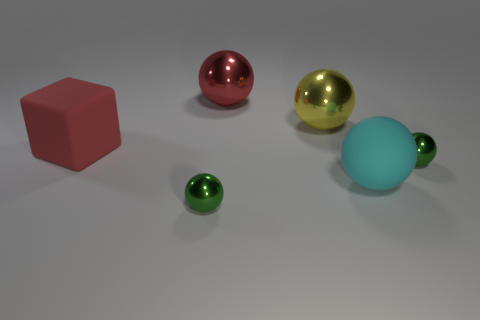There is a small metallic object right of the big cyan matte object; what is its shape?
Provide a short and direct response. Sphere. Do the large rubber object to the right of the large red matte cube and the metallic ball that is to the right of the cyan matte ball have the same color?
Your answer should be very brief. No. What is the size of the ball that is the same color as the big matte block?
Keep it short and to the point. Large. Is there a rubber object?
Offer a terse response. Yes. What is the shape of the green shiny object behind the thing that is in front of the rubber object that is on the right side of the big rubber cube?
Your response must be concise. Sphere. How many red things are left of the big block?
Ensure brevity in your answer.  0. Is the material of the red thing on the right side of the big block the same as the red block?
Your response must be concise. No. How many other objects are the same shape as the red matte thing?
Your response must be concise. 0. There is a tiny metallic ball to the left of the small object that is on the right side of the big cyan matte ball; how many tiny shiny things are to the right of it?
Ensure brevity in your answer.  1. What is the color of the rubber thing in front of the red cube?
Make the answer very short. Cyan. 